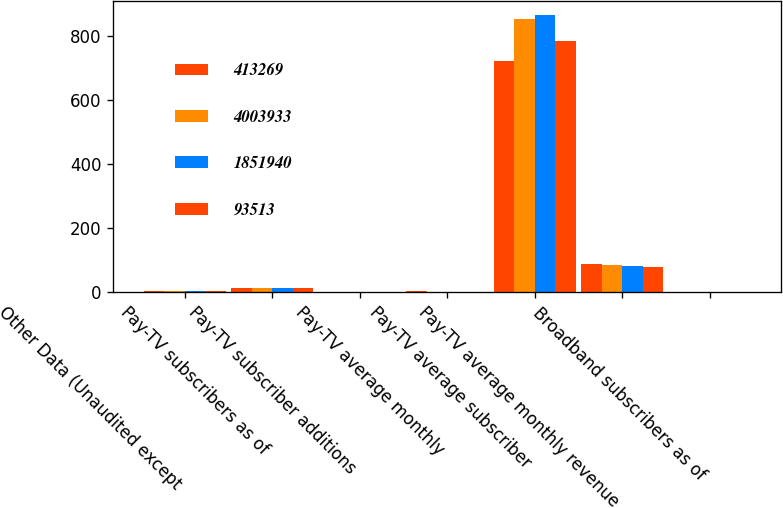<chart> <loc_0><loc_0><loc_500><loc_500><stacked_bar_chart><ecel><fcel>Other Data (Unaudited except<fcel>Pay-TV subscribers as of<fcel>Pay-TV subscriber additions<fcel>Pay-TV average monthly<fcel>Pay-TV average subscriber<fcel>Pay-TV average monthly revenue<fcel>Broadband subscribers as of<nl><fcel>413269<fcel>2.705<fcel>13.9<fcel>0.08<fcel>1.71<fcel>723<fcel>86.79<fcel>0.62<nl><fcel>4.00393e+06<fcel>2.705<fcel>13.98<fcel>0.08<fcel>1.59<fcel>853<fcel>83.77<fcel>0.58<nl><fcel>1.85194e+06<fcel>2.705<fcel>14.06<fcel>0<fcel>1.58<fcel>866<fcel>80.37<fcel>0.44<nl><fcel>93513<fcel>2.705<fcel>14.06<fcel>0.09<fcel>1.57<fcel>784<fcel>76.98<fcel>0.18<nl></chart> 